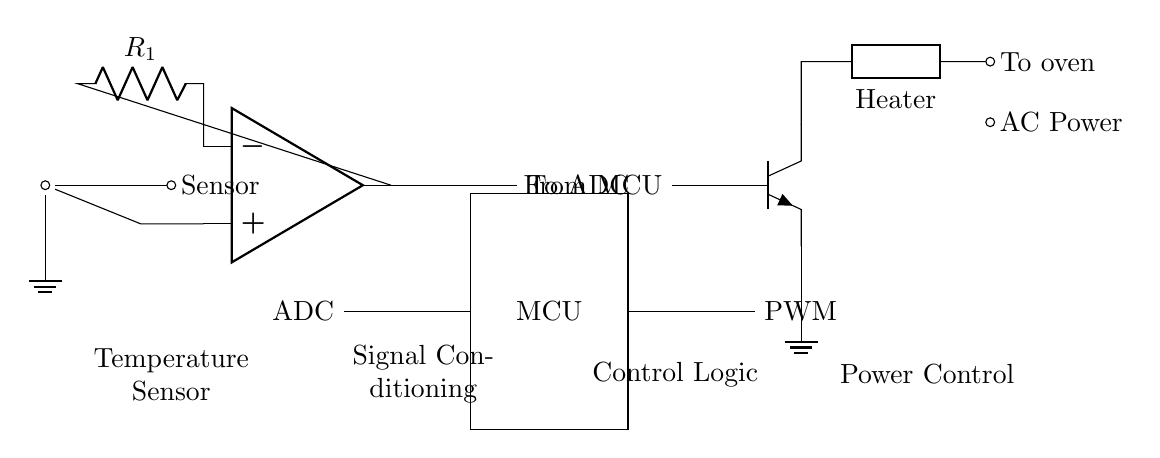What type of sensor is used in this circuit? The circuit has a thermistor, which is a type of temperature sensor. It detects changes in temperature by altering its resistance.
Answer: thermistor What is the purpose of the operational amplifier in this circuit? The operational amplifier is used for signal conditioning by amplifying the voltage produced by the thermistor before sending it to the ADC.
Answer: signal conditioning Which component provides the heating element? The heating element in the circuit is represented by a generic component labeled as "Heater", which connects to the power output from the transistor.
Answer: Heater What type of control signal does the microcontroller output? The microcontroller outputs a PWM (Pulse Width Modulation) signal, which is used to control the power delivered to the heating element.
Answer: PWM How does the microcontroller receive temperature data? The microcontroller receives temperature data via an ADC (Analog to Digital Converter), which converts the analog signal from the operational amplifier into a digital format for processing.
Answer: ADC What is the transistor type used in the power control section? The circuit uses an NPN transistor as indicated by the symbol shown in the diagram. NPN transistors are commonly used for switching and amplification.
Answer: NPN 